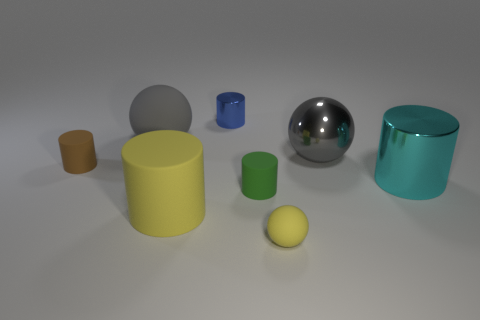There is a big cylinder that is the same color as the small sphere; what is it made of?
Give a very brief answer. Rubber. Are there any small rubber objects that have the same shape as the big yellow matte thing?
Give a very brief answer. Yes. What size is the yellow matte thing that is on the right side of the blue metallic cylinder?
Your answer should be compact. Small. There is a cylinder that is the same size as the cyan object; what is its material?
Keep it short and to the point. Rubber. Is the number of green rubber balls greater than the number of gray rubber spheres?
Your response must be concise. No. There is a metal cylinder that is behind the small brown thing that is behind the tiny yellow ball; how big is it?
Offer a terse response. Small. There is a yellow thing that is the same size as the green cylinder; what shape is it?
Provide a short and direct response. Sphere. What is the shape of the large object on the right side of the gray sphere right of the large rubber object that is to the left of the big yellow thing?
Ensure brevity in your answer.  Cylinder. There is a sphere that is to the left of the small blue thing; is its color the same as the large metallic object that is behind the brown thing?
Provide a short and direct response. Yes. How many blue metal cylinders are there?
Keep it short and to the point. 1. 